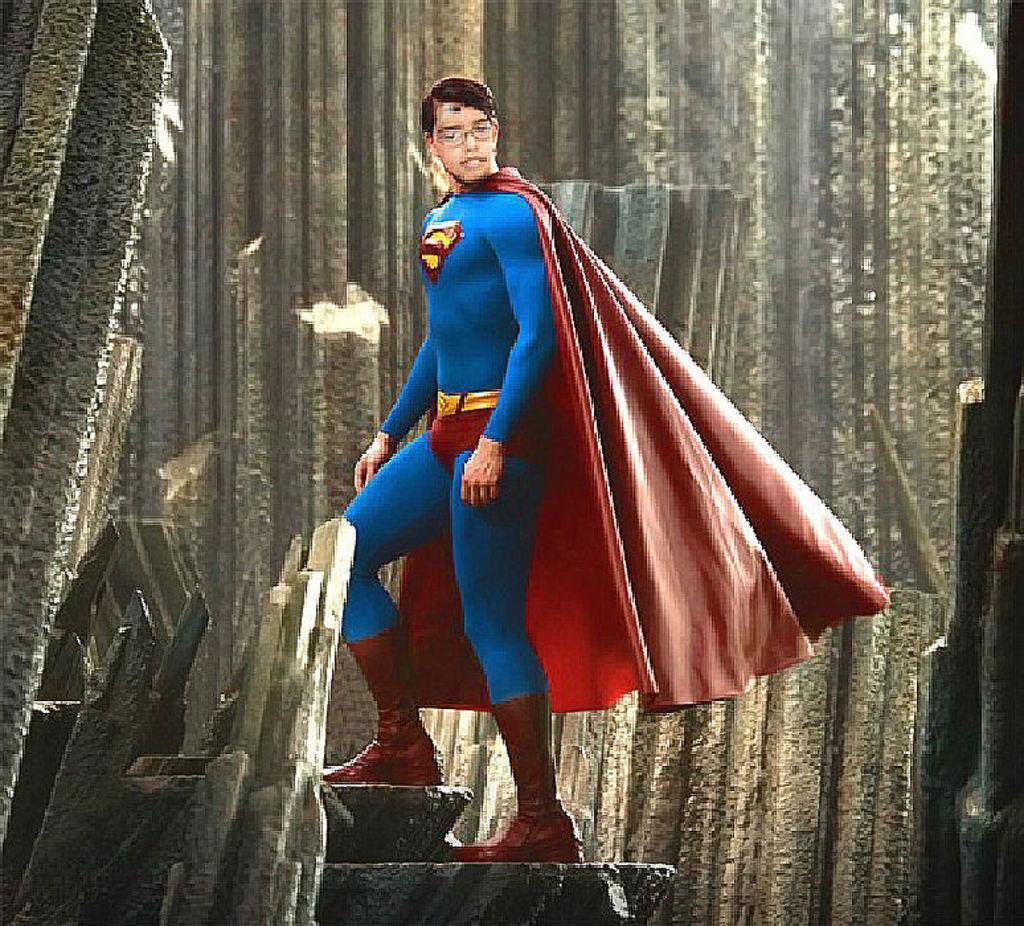What is depicted in the animated photograph in the image? There is an animated photograph of a superman in the image. Where is the superman located in the image? The superman is standing on the steps. What can be seen in the background of the image? There is a wall with pieces visible in the background of the image. How many monkeys are sitting on the wall in the image? There are no monkeys present in the image; it features an animated photograph of a superman standing on the steps. What type of pollution can be seen in the image? There is no pollution visible in the image; it only shows an animated photograph of a superman standing on the steps and a wall in the background. 